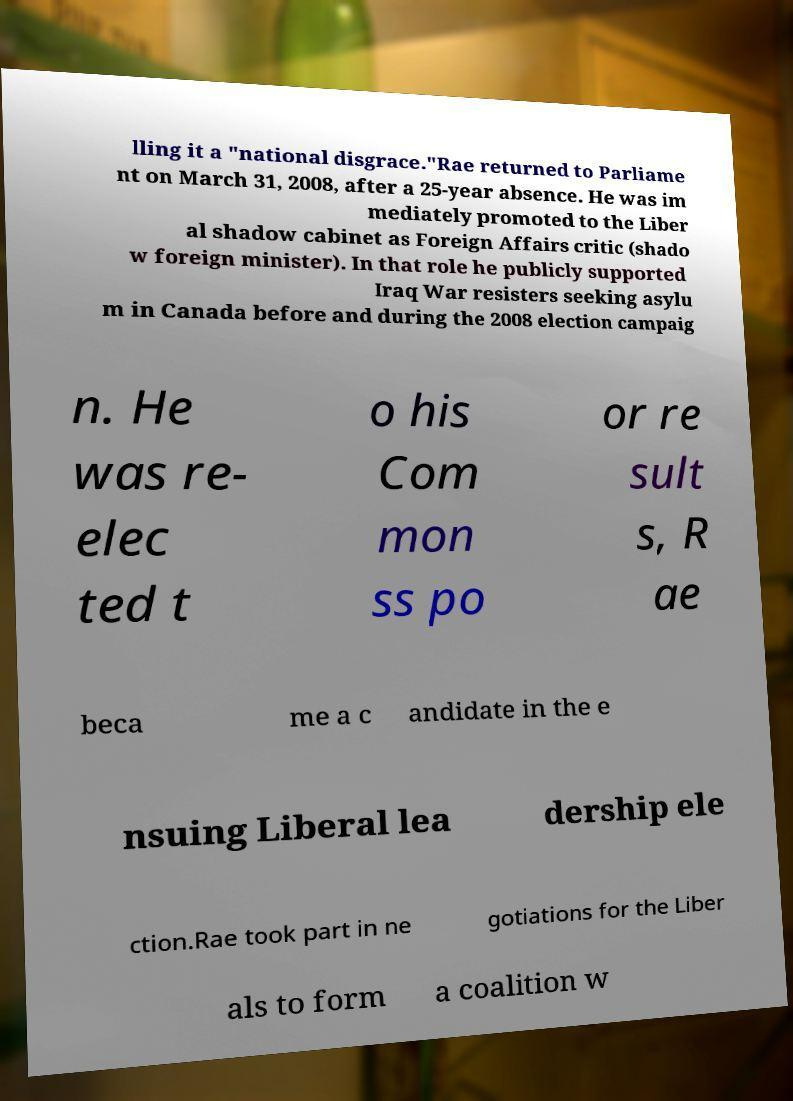I need the written content from this picture converted into text. Can you do that? lling it a "national disgrace."Rae returned to Parliame nt on March 31, 2008, after a 25-year absence. He was im mediately promoted to the Liber al shadow cabinet as Foreign Affairs critic (shado w foreign minister). In that role he publicly supported Iraq War resisters seeking asylu m in Canada before and during the 2008 election campaig n. He was re- elec ted t o his Com mon ss po or re sult s, R ae beca me a c andidate in the e nsuing Liberal lea dership ele ction.Rae took part in ne gotiations for the Liber als to form a coalition w 